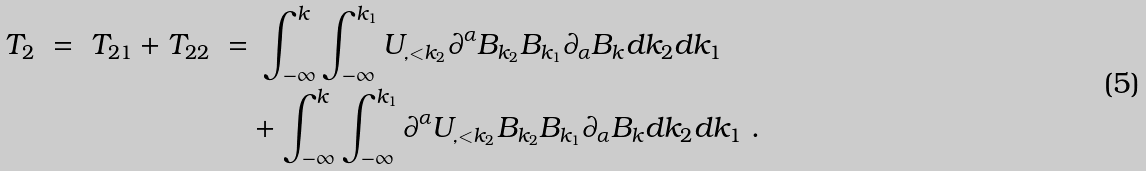<formula> <loc_0><loc_0><loc_500><loc_500>T _ { 2 } \ = \ T _ { 2 1 } + T _ { 2 2 } \ = & \ \int _ { - \infty } ^ { k } \int _ { - \infty } ^ { k _ { 1 } } U _ { , < k _ { 2 } } \partial ^ { \alpha } B _ { k _ { 2 } } B _ { k _ { 1 } } \partial _ { \alpha } B _ { k } d k _ { 2 } d k _ { 1 } \\ & + \int _ { - \infty } ^ { k } \int _ { - \infty } ^ { k _ { 1 } } \partial ^ { \alpha } U _ { , < k _ { 2 } } B _ { k _ { 2 } } B _ { k _ { 1 } } \partial _ { \alpha } B _ { k } d k _ { 2 } d k _ { 1 } \ .</formula> 